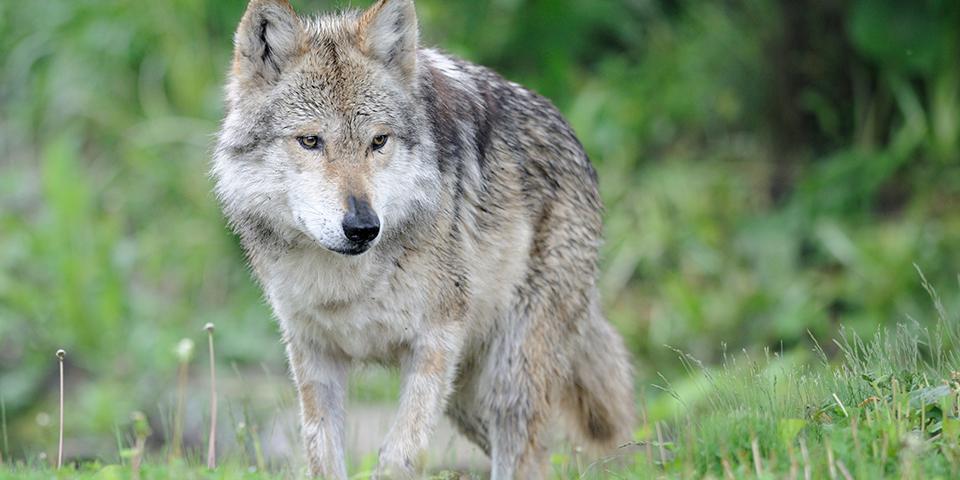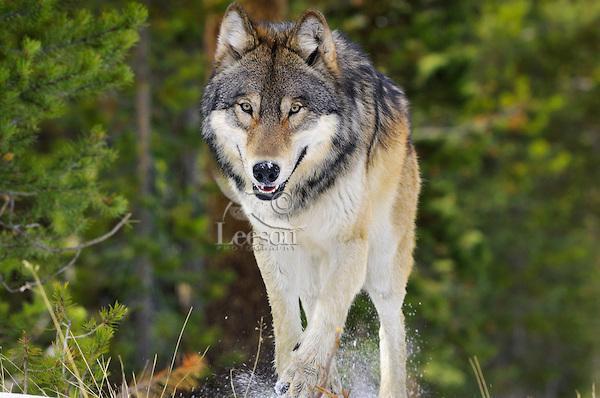The first image is the image on the left, the second image is the image on the right. For the images displayed, is the sentence "In each image, multiple wolves interact playfully on a snowy field in front of evergreens." factually correct? Answer yes or no. No. The first image is the image on the left, the second image is the image on the right. Given the left and right images, does the statement "The right image contains exactly two wolves." hold true? Answer yes or no. No. 